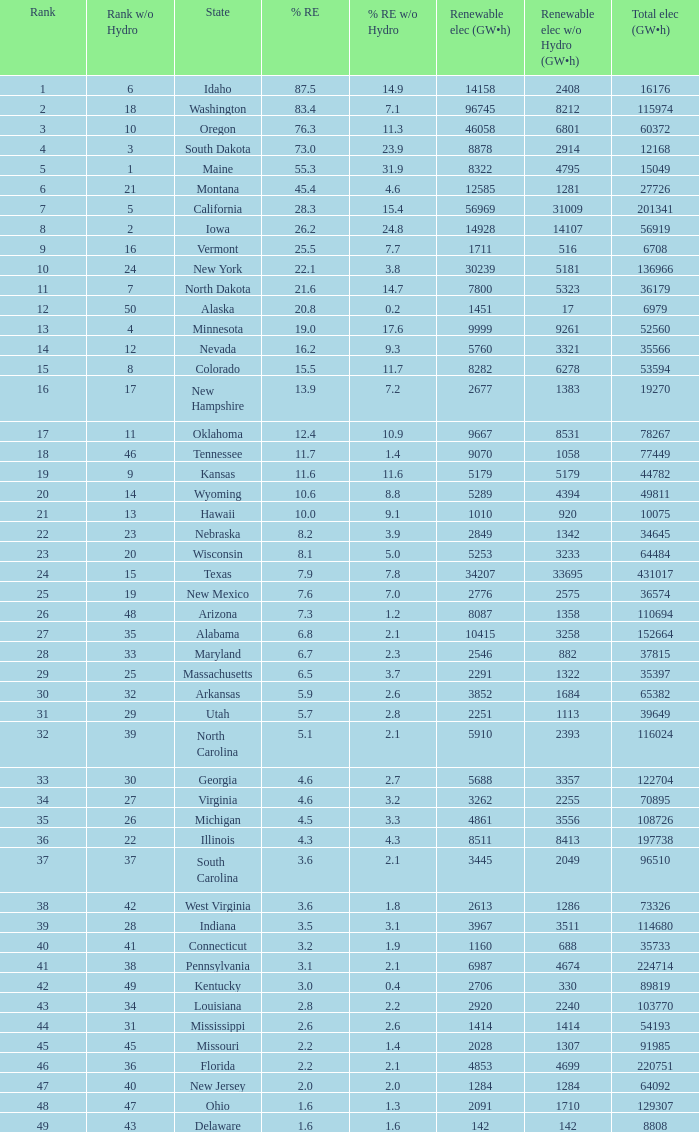When renewable electricity is 5760 (gw×h) what is the minimum amount of renewable elecrrixity without hydrogen power? 3321.0. 